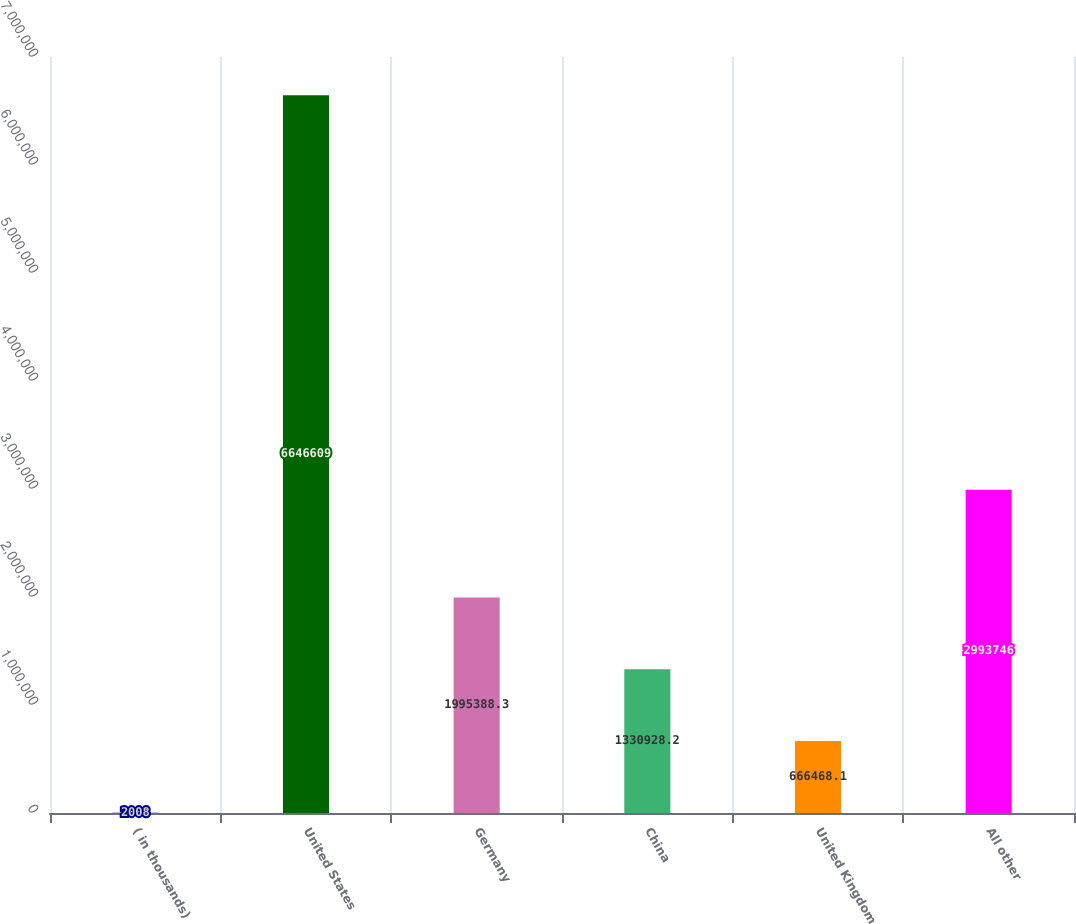<chart> <loc_0><loc_0><loc_500><loc_500><bar_chart><fcel>( in thousands)<fcel>United States<fcel>Germany<fcel>China<fcel>United Kingdom<fcel>All other<nl><fcel>2008<fcel>6.64661e+06<fcel>1.99539e+06<fcel>1.33093e+06<fcel>666468<fcel>2.99375e+06<nl></chart> 